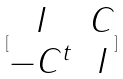Convert formula to latex. <formula><loc_0><loc_0><loc_500><loc_500>[ \begin{matrix} I & C \\ - C ^ { t } & I \end{matrix} ]</formula> 